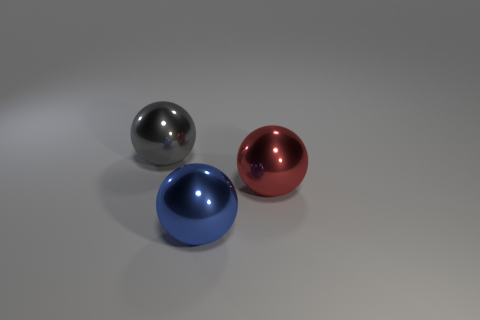What number of big brown rubber blocks are there?
Your answer should be compact. 0. There is a metallic thing that is on the right side of the blue ball; what color is it?
Ensure brevity in your answer.  Red. The blue sphere has what size?
Provide a short and direct response. Large. What color is the metallic thing that is in front of the metallic object that is to the right of the blue sphere?
Ensure brevity in your answer.  Blue. There is a big thing on the left side of the big blue object; is its shape the same as the large red metallic thing?
Make the answer very short. Yes. How many big objects are both to the left of the big blue metallic ball and right of the gray metallic thing?
Your answer should be very brief. 0. The ball that is to the left of the object in front of the ball to the right of the blue shiny object is what color?
Offer a very short reply. Gray. There is a shiny sphere that is in front of the big red object; how many big shiny balls are left of it?
Offer a terse response. 1. What number of other things are there of the same shape as the blue thing?
Keep it short and to the point. 2. What number of things are gray metallic things or large gray spheres that are to the left of the large blue sphere?
Your response must be concise. 1. 